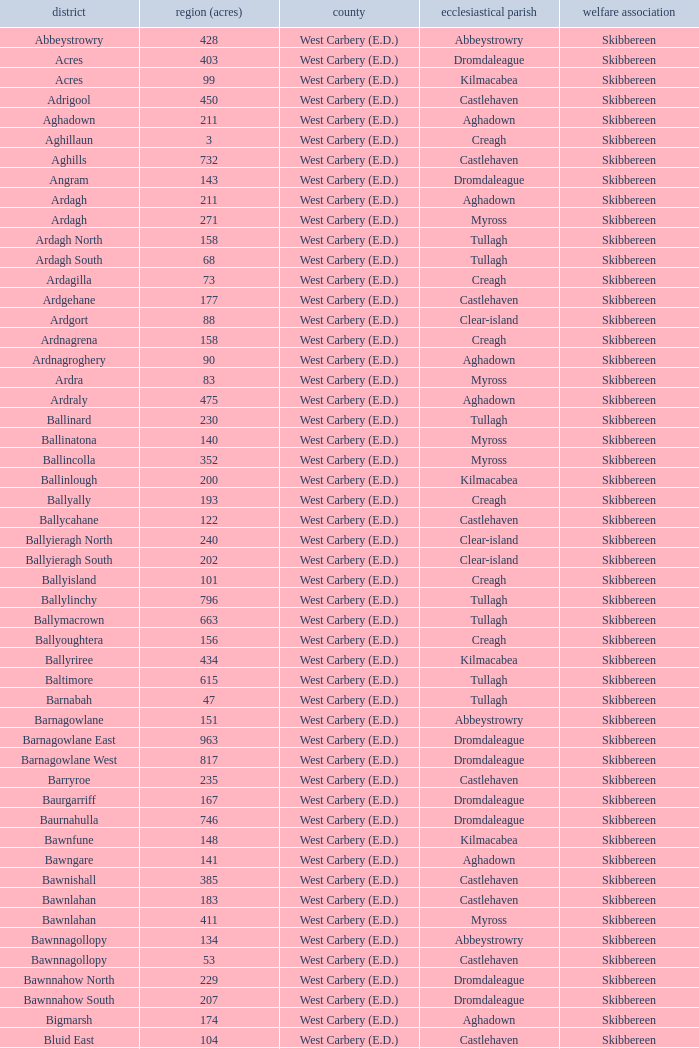What are the areas (in acres) of the Kilnahera East townland? 257.0. 